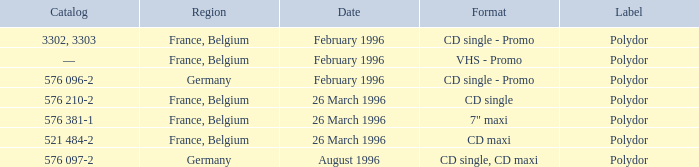Name the catalog for 26 march 1996 576 210-2, 576 381-1, 521 484-2. I'm looking to parse the entire table for insights. Could you assist me with that? {'header': ['Catalog', 'Region', 'Date', 'Format', 'Label'], 'rows': [['3302, 3303', 'France, Belgium', 'February 1996', 'CD single - Promo', 'Polydor'], ['—', 'France, Belgium', 'February 1996', 'VHS - Promo', 'Polydor'], ['576 096-2', 'Germany', 'February 1996', 'CD single - Promo', 'Polydor'], ['576 210-2', 'France, Belgium', '26 March 1996', 'CD single', 'Polydor'], ['576 381-1', 'France, Belgium', '26 March 1996', '7" maxi', 'Polydor'], ['521 484-2', 'France, Belgium', '26 March 1996', 'CD maxi', 'Polydor'], ['576 097-2', 'Germany', 'August 1996', 'CD single, CD maxi', 'Polydor']]} 